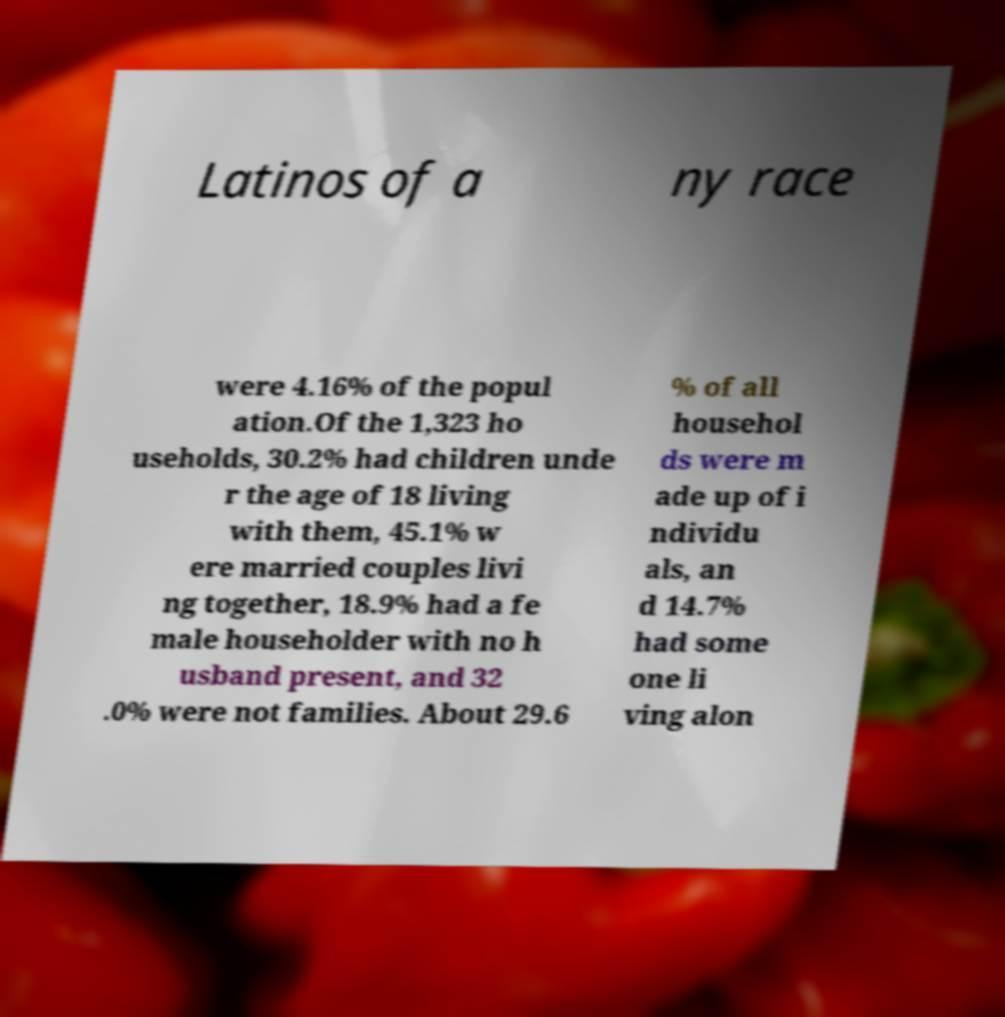Could you assist in decoding the text presented in this image and type it out clearly? Latinos of a ny race were 4.16% of the popul ation.Of the 1,323 ho useholds, 30.2% had children unde r the age of 18 living with them, 45.1% w ere married couples livi ng together, 18.9% had a fe male householder with no h usband present, and 32 .0% were not families. About 29.6 % of all househol ds were m ade up of i ndividu als, an d 14.7% had some one li ving alon 